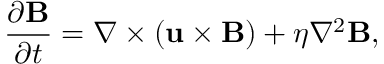Convert formula to latex. <formula><loc_0><loc_0><loc_500><loc_500>\frac { \partial B } { \partial t } = \nabla \times \left ( u \times B \right ) + \eta \nabla ^ { 2 } B ,</formula> 